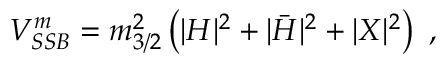Convert formula to latex. <formula><loc_0><loc_0><loc_500><loc_500>V _ { S S B } ^ { m } = m _ { 3 / 2 } ^ { 2 } \left ( | H | ^ { 2 } + | \bar { H } | ^ { 2 } + | X | ^ { 2 } \right ) ,</formula> 